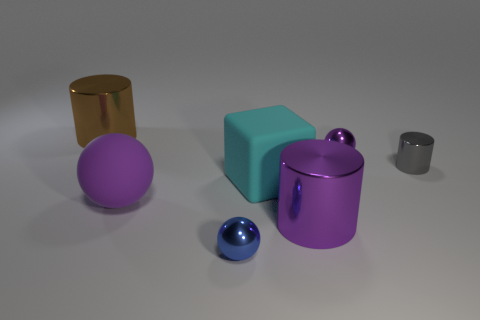What is the shape of the purple shiny thing that is behind the large purple matte ball?
Offer a terse response. Sphere. How many objects are yellow blocks or metallic objects that are in front of the small gray metal cylinder?
Make the answer very short. 2. Does the gray object have the same material as the small purple object?
Ensure brevity in your answer.  Yes. Are there the same number of big metallic things that are in front of the small blue sphere and brown metallic things in front of the large purple sphere?
Your answer should be compact. Yes. How many brown objects are behind the large cyan thing?
Keep it short and to the point. 1. How many objects are either large cyan blocks or tiny blue rubber blocks?
Offer a terse response. 1. How many shiny spheres are the same size as the brown cylinder?
Offer a terse response. 0. The big cyan matte thing that is left of the large purple cylinder that is behind the small blue metal ball is what shape?
Provide a succinct answer. Cube. Is the number of small cyan blocks less than the number of small balls?
Provide a short and direct response. Yes. The large metal thing that is in front of the small purple sphere is what color?
Provide a succinct answer. Purple. 